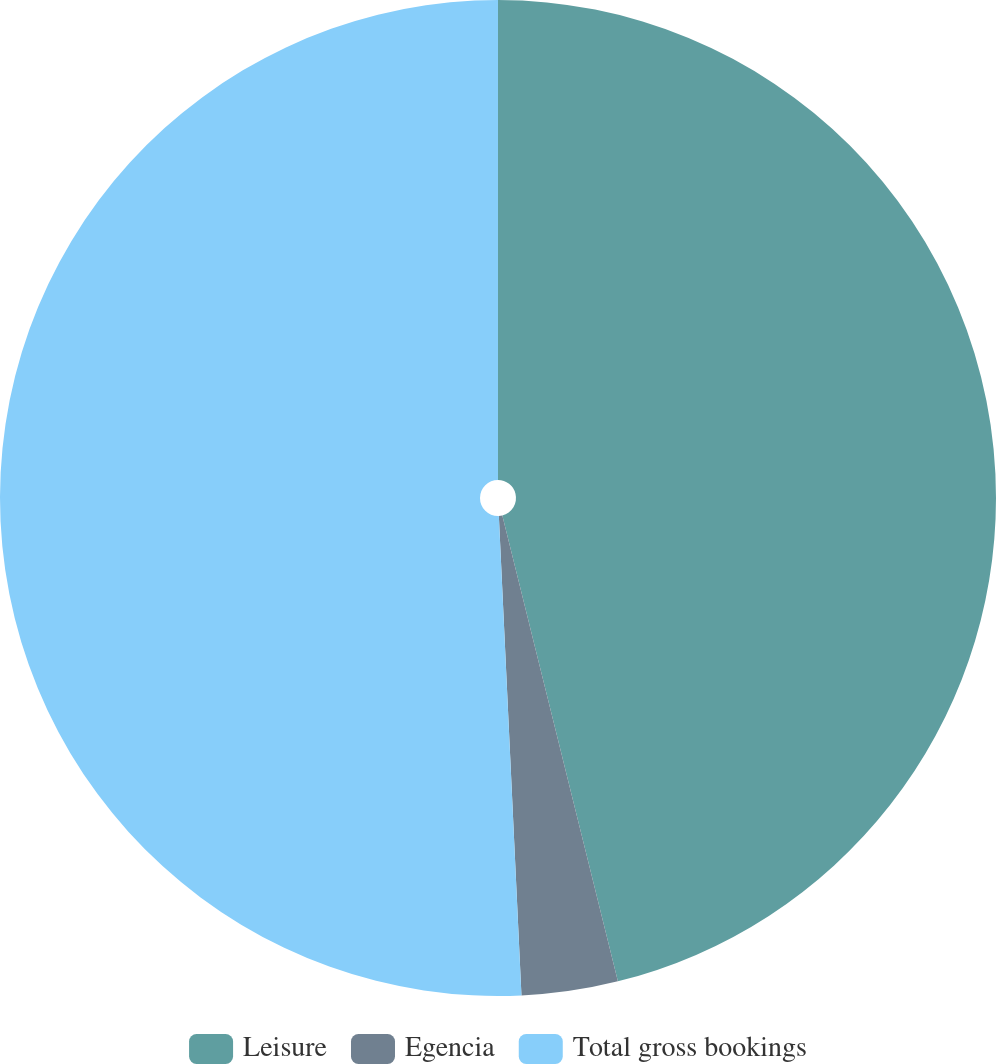<chart> <loc_0><loc_0><loc_500><loc_500><pie_chart><fcel>Leisure<fcel>Egencia<fcel>Total gross bookings<nl><fcel>46.13%<fcel>3.12%<fcel>50.75%<nl></chart> 